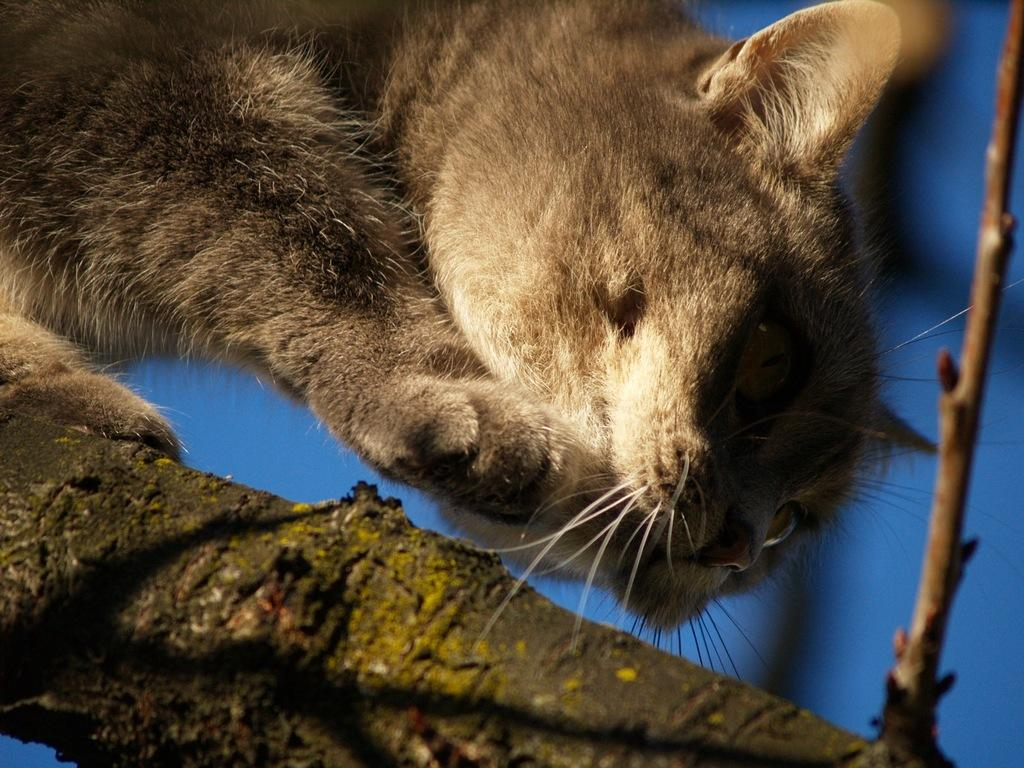What type of animal is in the image? There is a cat in the image. Can you describe the color pattern of the cat? The cat has brown and cream colors. What color is the background of the image? The background of the image is blue. What type of quilt is being used to cover the cat in the image? There is no quilt present in the image, and the cat is not being covered by anything. 